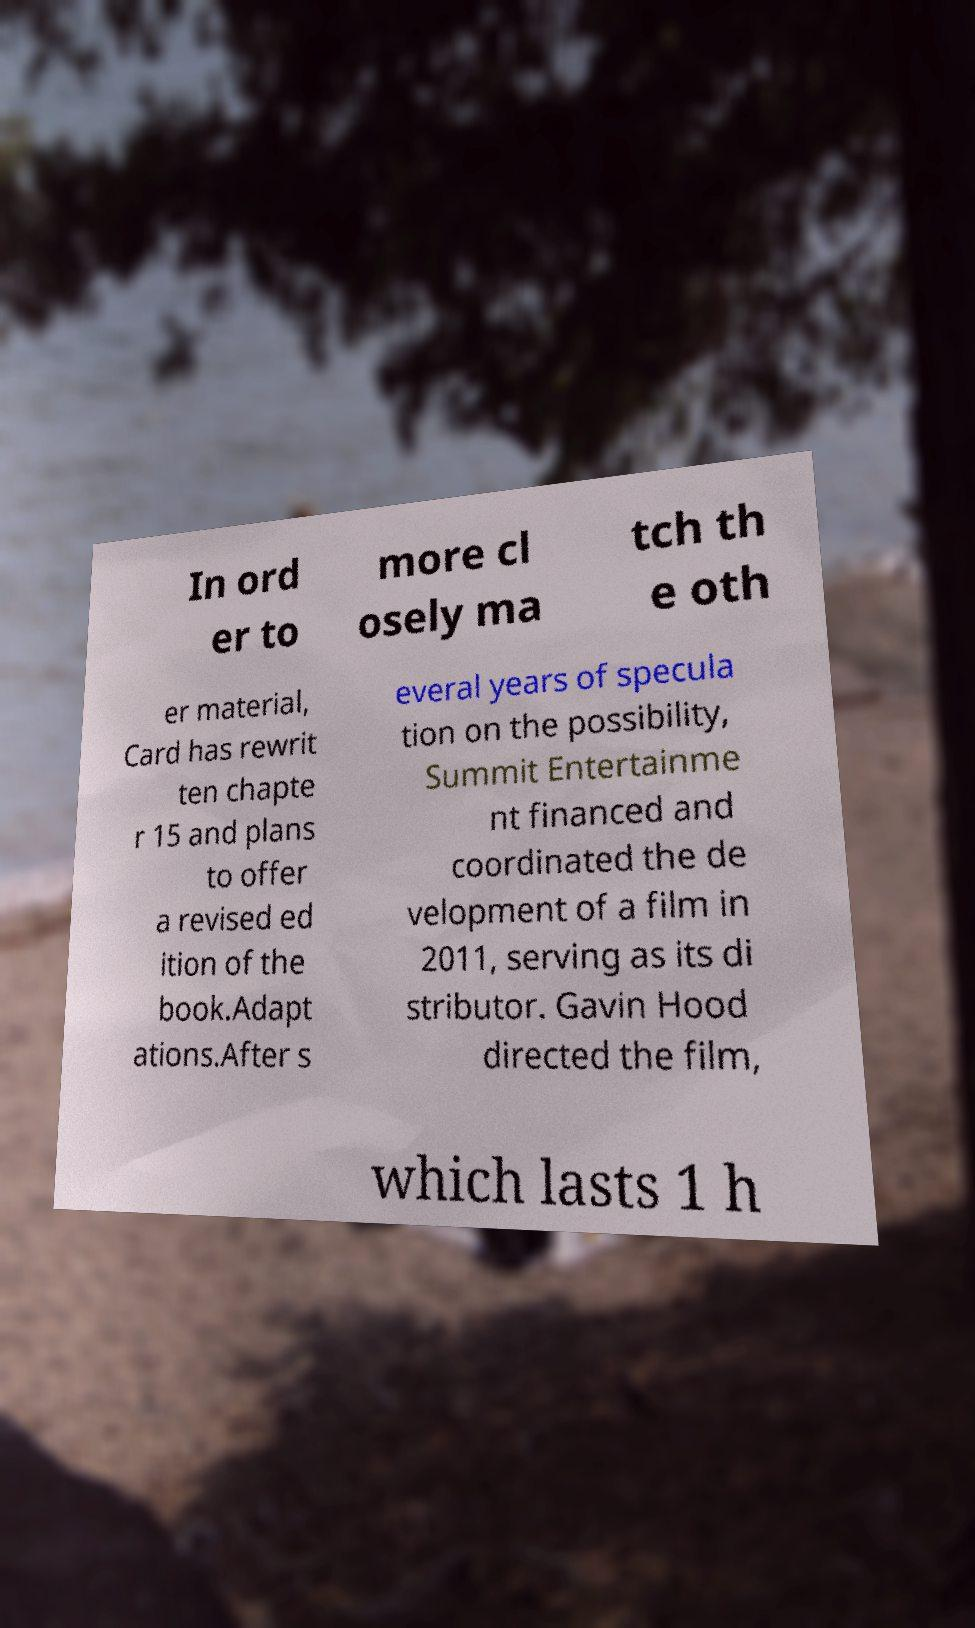Can you accurately transcribe the text from the provided image for me? In ord er to more cl osely ma tch th e oth er material, Card has rewrit ten chapte r 15 and plans to offer a revised ed ition of the book.Adapt ations.After s everal years of specula tion on the possibility, Summit Entertainme nt financed and coordinated the de velopment of a film in 2011, serving as its di stributor. Gavin Hood directed the film, which lasts 1 h 